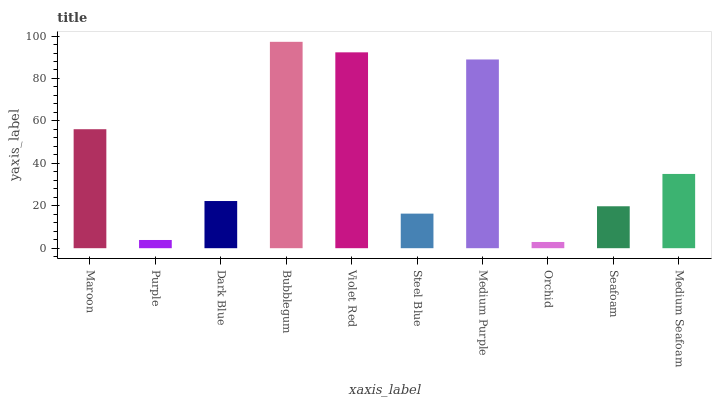Is Orchid the minimum?
Answer yes or no. Yes. Is Bubblegum the maximum?
Answer yes or no. Yes. Is Purple the minimum?
Answer yes or no. No. Is Purple the maximum?
Answer yes or no. No. Is Maroon greater than Purple?
Answer yes or no. Yes. Is Purple less than Maroon?
Answer yes or no. Yes. Is Purple greater than Maroon?
Answer yes or no. No. Is Maroon less than Purple?
Answer yes or no. No. Is Medium Seafoam the high median?
Answer yes or no. Yes. Is Dark Blue the low median?
Answer yes or no. Yes. Is Seafoam the high median?
Answer yes or no. No. Is Violet Red the low median?
Answer yes or no. No. 